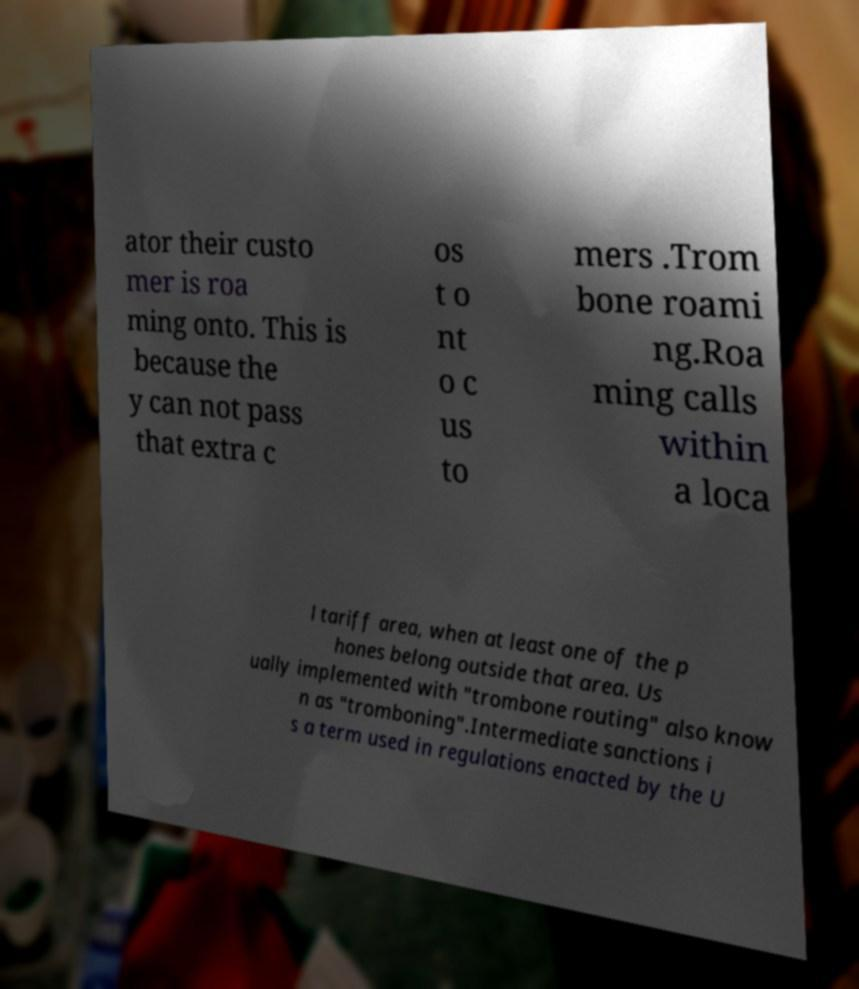What messages or text are displayed in this image? I need them in a readable, typed format. ator their custo mer is roa ming onto. This is because the y can not pass that extra c os t o nt o c us to mers .Trom bone roami ng.Roa ming calls within a loca l tariff area, when at least one of the p hones belong outside that area. Us ually implemented with "trombone routing" also know n as "tromboning".Intermediate sanctions i s a term used in regulations enacted by the U 